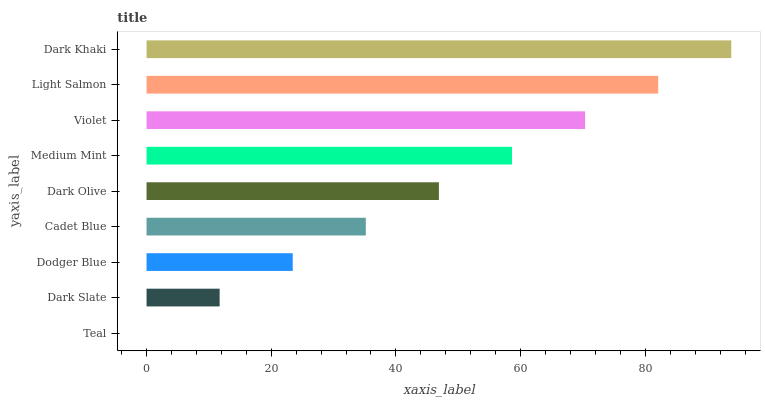Is Teal the minimum?
Answer yes or no. Yes. Is Dark Khaki the maximum?
Answer yes or no. Yes. Is Dark Slate the minimum?
Answer yes or no. No. Is Dark Slate the maximum?
Answer yes or no. No. Is Dark Slate greater than Teal?
Answer yes or no. Yes. Is Teal less than Dark Slate?
Answer yes or no. Yes. Is Teal greater than Dark Slate?
Answer yes or no. No. Is Dark Slate less than Teal?
Answer yes or no. No. Is Dark Olive the high median?
Answer yes or no. Yes. Is Dark Olive the low median?
Answer yes or no. Yes. Is Dark Slate the high median?
Answer yes or no. No. Is Teal the low median?
Answer yes or no. No. 